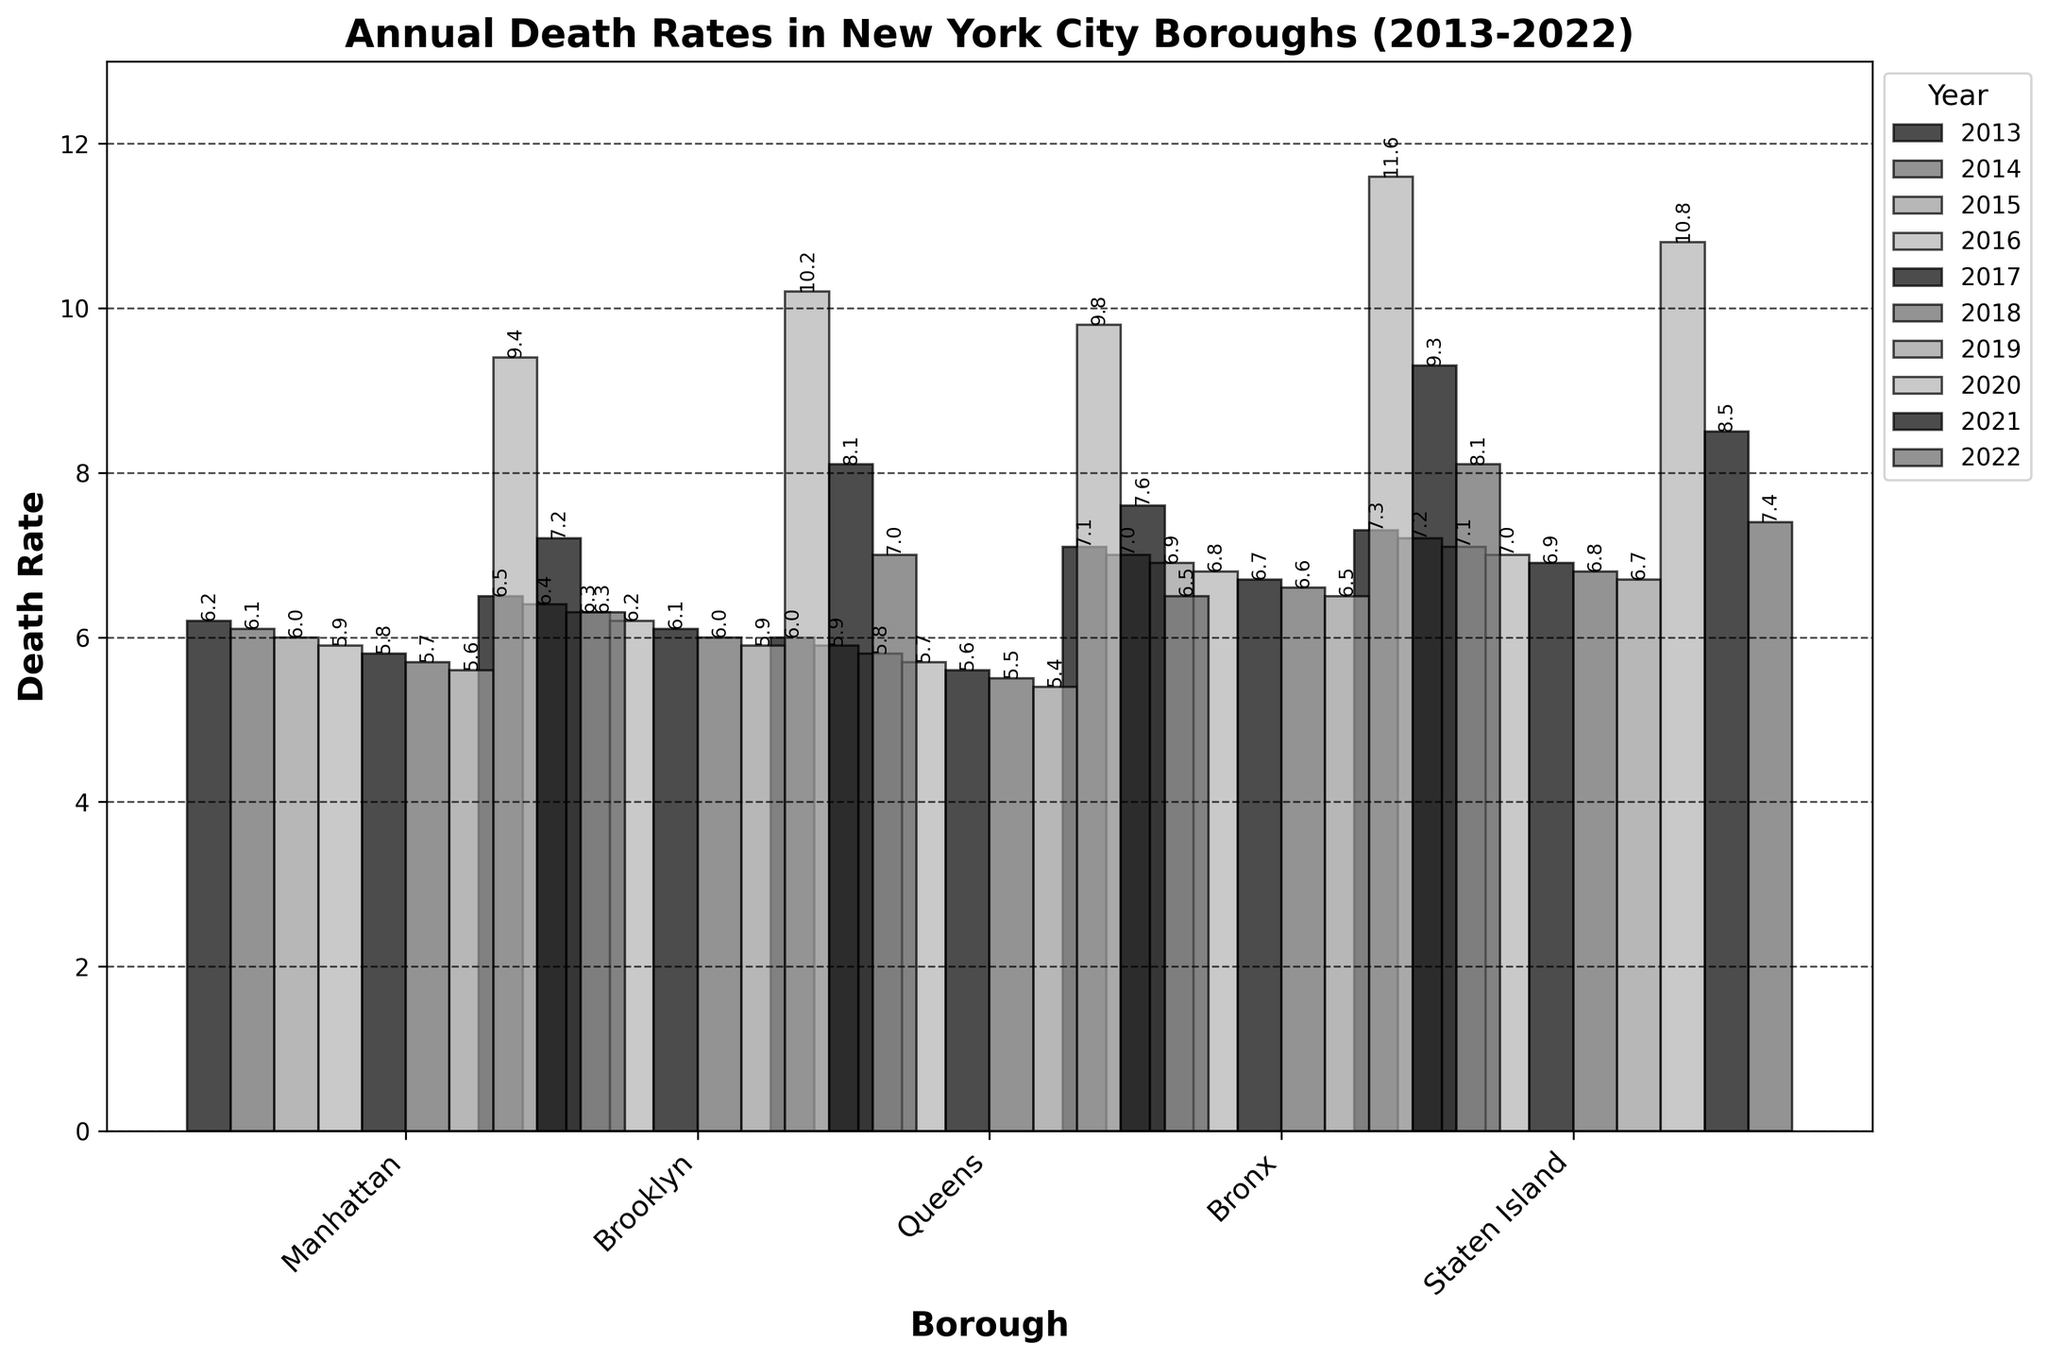What's the overall trend in the death rates from 2013 to 2022 for each borough? To determine the trend, observe the height of bars for each borough across years. All boroughs show a general decline from 2013 to 2019, followed by a sharp increase in 2020, then a slight decline again until 2022.
Answer: Overall decline with a peak in 2020 Which borough had the highest death rate in 2022? Locate the tallest bar in the year 2022 among all boroughs. The Bronx has the highest death rate in 2022.
Answer: Bronx How did the death rate in Queens change from 2019 to 2020? Compare the height of the bars for Queens in 2019 and 2020. The death rate in Queens increased from 5.4 in 2019 to 9.8 in 2020.
Answer: Increased Which borough experienced the smallest increase in death rate from 2019 to 2020? Calculate the difference in death rates from 2019 to 2020 for each borough. Manhattan's death rate increased from 5.6 to 9.4, Brooklyn from 5.9 to 10.2, Queens from 5.4 to 9.8, Bronx from 6.5 to 11.6, and Staten Island from 6.7 to 10.8. The smallest increase is in Queens (4.4).
Answer: Queens In which year did Manhattan experience its highest death rate? Identify the tallest bar for Manhattan across all years. Manhattan experienced its highest death rate in 2020.
Answer: 2020 What is the percentage increase of death rates in the Bronx from 2019 to 2020? Calculate the percentage increase using the formula: [(Death Rate in 2020 - Death Rate in 2019) / Death Rate in 2019] * 100. For the Bronx: [(11.6 - 6.5) / 6.5] * 100 = 78.46%.
Answer: 78.46% Which borough had the lowest death rate in 2018? Find the shortest bar for the year 2018. Queens had the lowest death rate in 2018 at 5.5.
Answer: Queens How does the death rate in Brooklyn in 2022 compare to the average death rate in Brooklyn from 2013 to 2019? First, find the average death rate in Brooklyn from 2013 to 2019: (6.5 + 6.4 + 6.3 + 6.2 + 6.1 + 6.0 + 5.9) / 7 = 6.2. The death rate in Brooklyn in 2022 is 7.0. Brooklyn's death rate in 2022 is higher than the average from 2013 to 2019.
Answer: Higher Between which two consecutive years did Staten Island see the highest decrease in death rate? Analyze the height of the bars for Staten Island to identify the year-to-year changes. The largest decrease was from 2020 (10.8) to 2021 (8.5), a difference of 2.3.
Answer: 2020 to 2021 